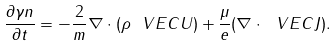<formula> <loc_0><loc_0><loc_500><loc_500>\frac { \partial \gamma n } { \partial t } = - \frac { 2 } { m } \nabla \cdot ( \rho \ V E C { U } ) + \frac { \mu } { e } ( \nabla \cdot \ V E C { J } ) .</formula> 